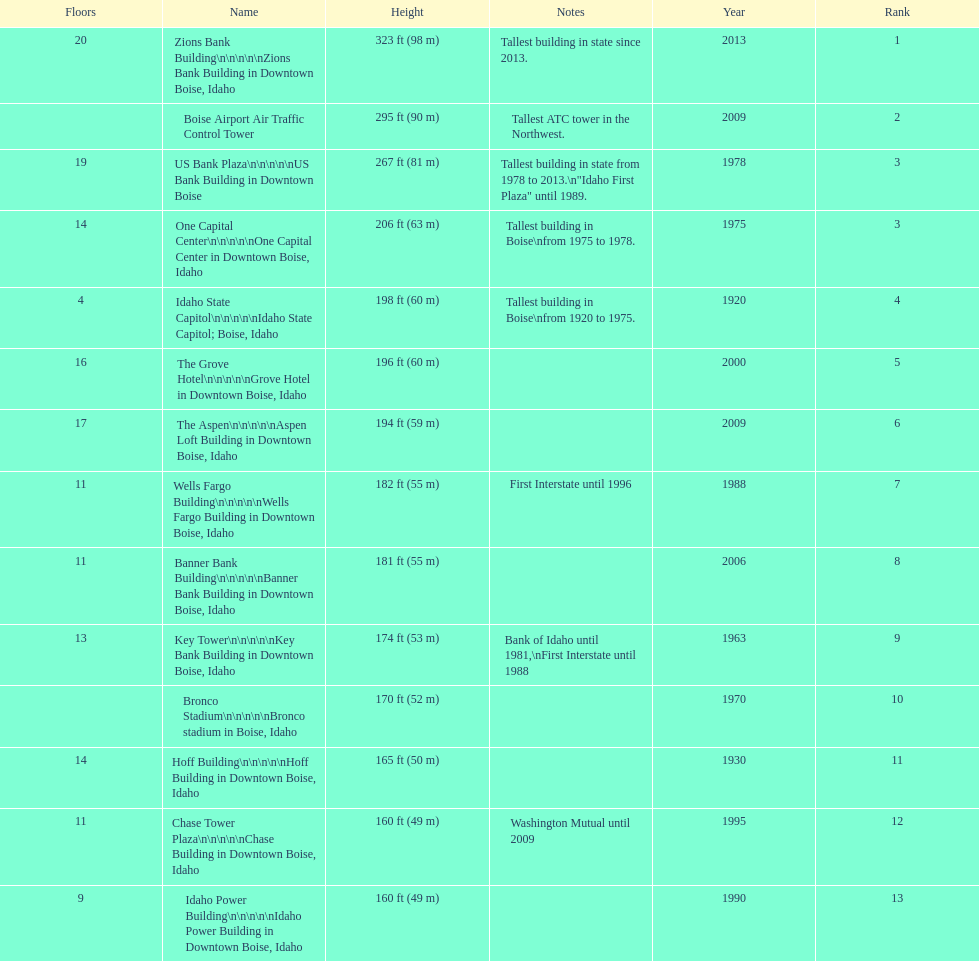How many of these buildings were built after 1975 8. 